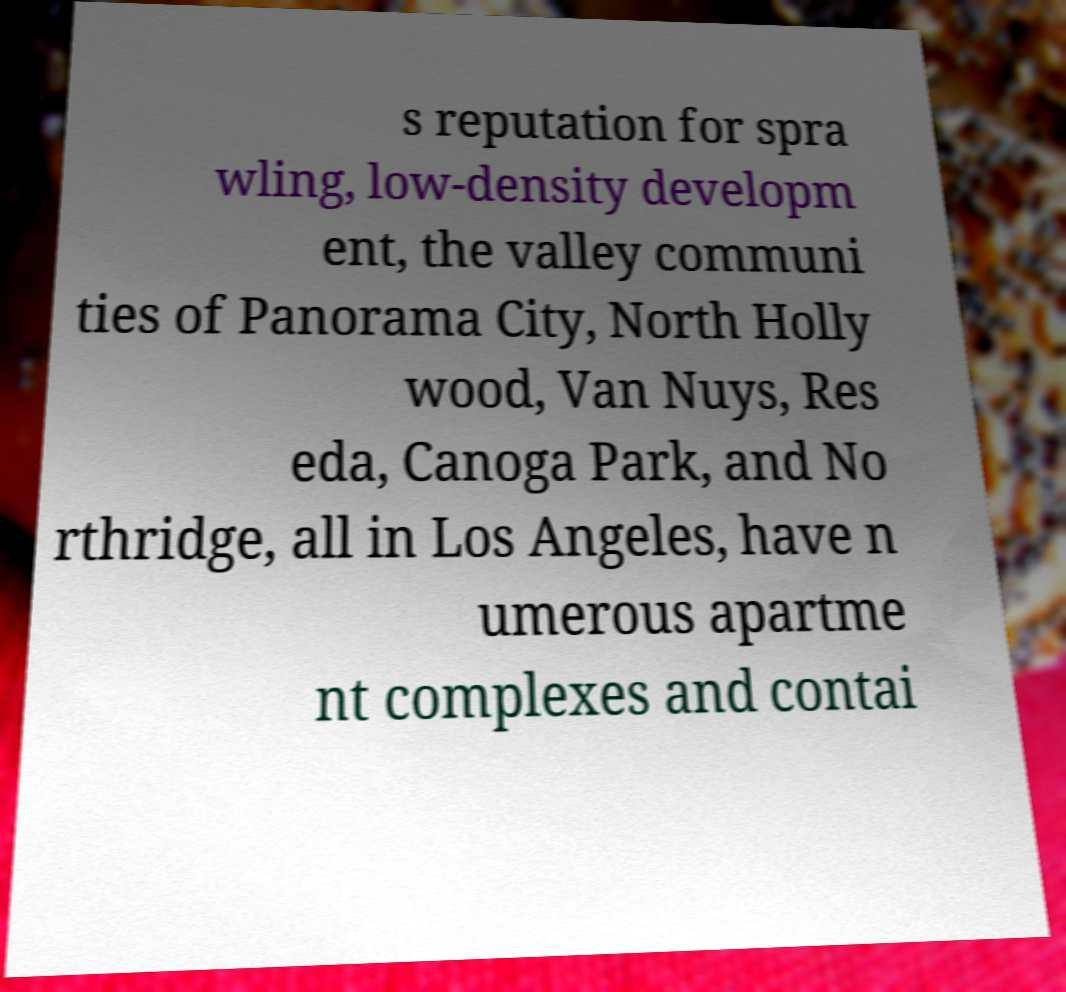Could you extract and type out the text from this image? s reputation for spra wling, low-density developm ent, the valley communi ties of Panorama City, North Holly wood, Van Nuys, Res eda, Canoga Park, and No rthridge, all in Los Angeles, have n umerous apartme nt complexes and contai 